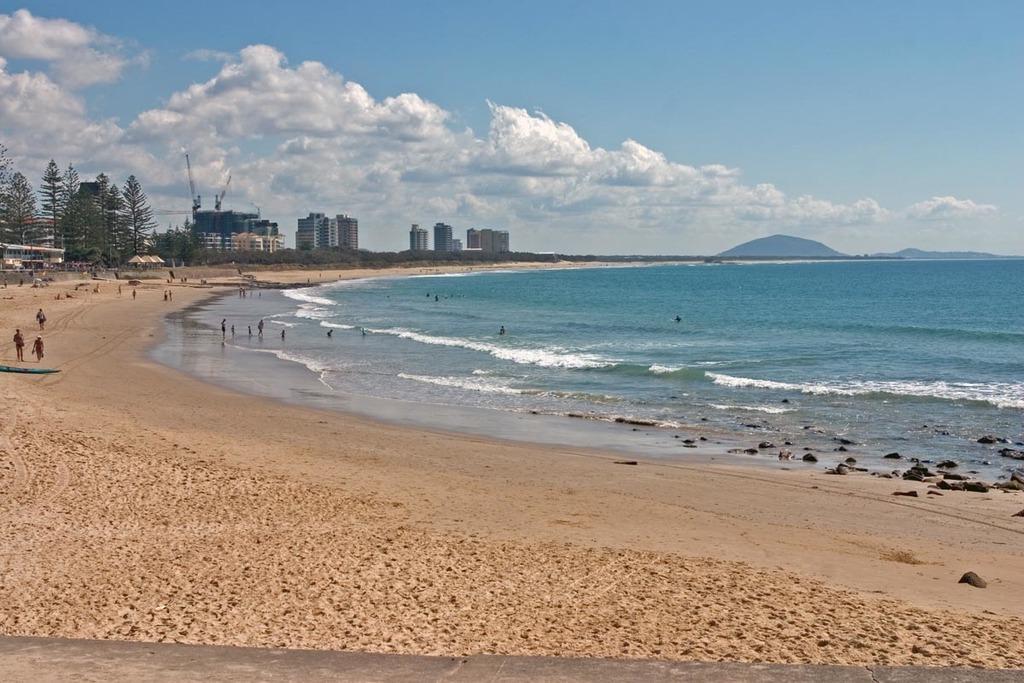In one or two sentences, can you explain what this image depicts? In this picture we can see stones, water, some people on sand, trees, umbrellas, buildings, mountains and some objects and in the background we can see the sky with clouds. 